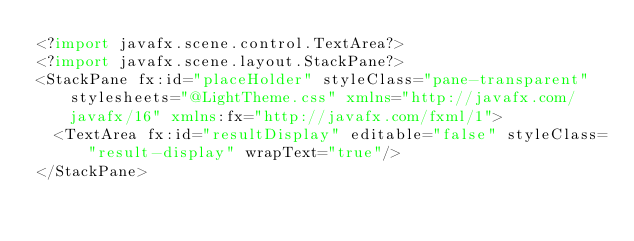<code> <loc_0><loc_0><loc_500><loc_500><_XML_><?import javafx.scene.control.TextArea?>
<?import javafx.scene.layout.StackPane?>
<StackPane fx:id="placeHolder" styleClass="pane-transparent" stylesheets="@LightTheme.css" xmlns="http://javafx.com/javafx/16" xmlns:fx="http://javafx.com/fxml/1">
  <TextArea fx:id="resultDisplay" editable="false" styleClass="result-display" wrapText="true"/>
</StackPane>
</code> 